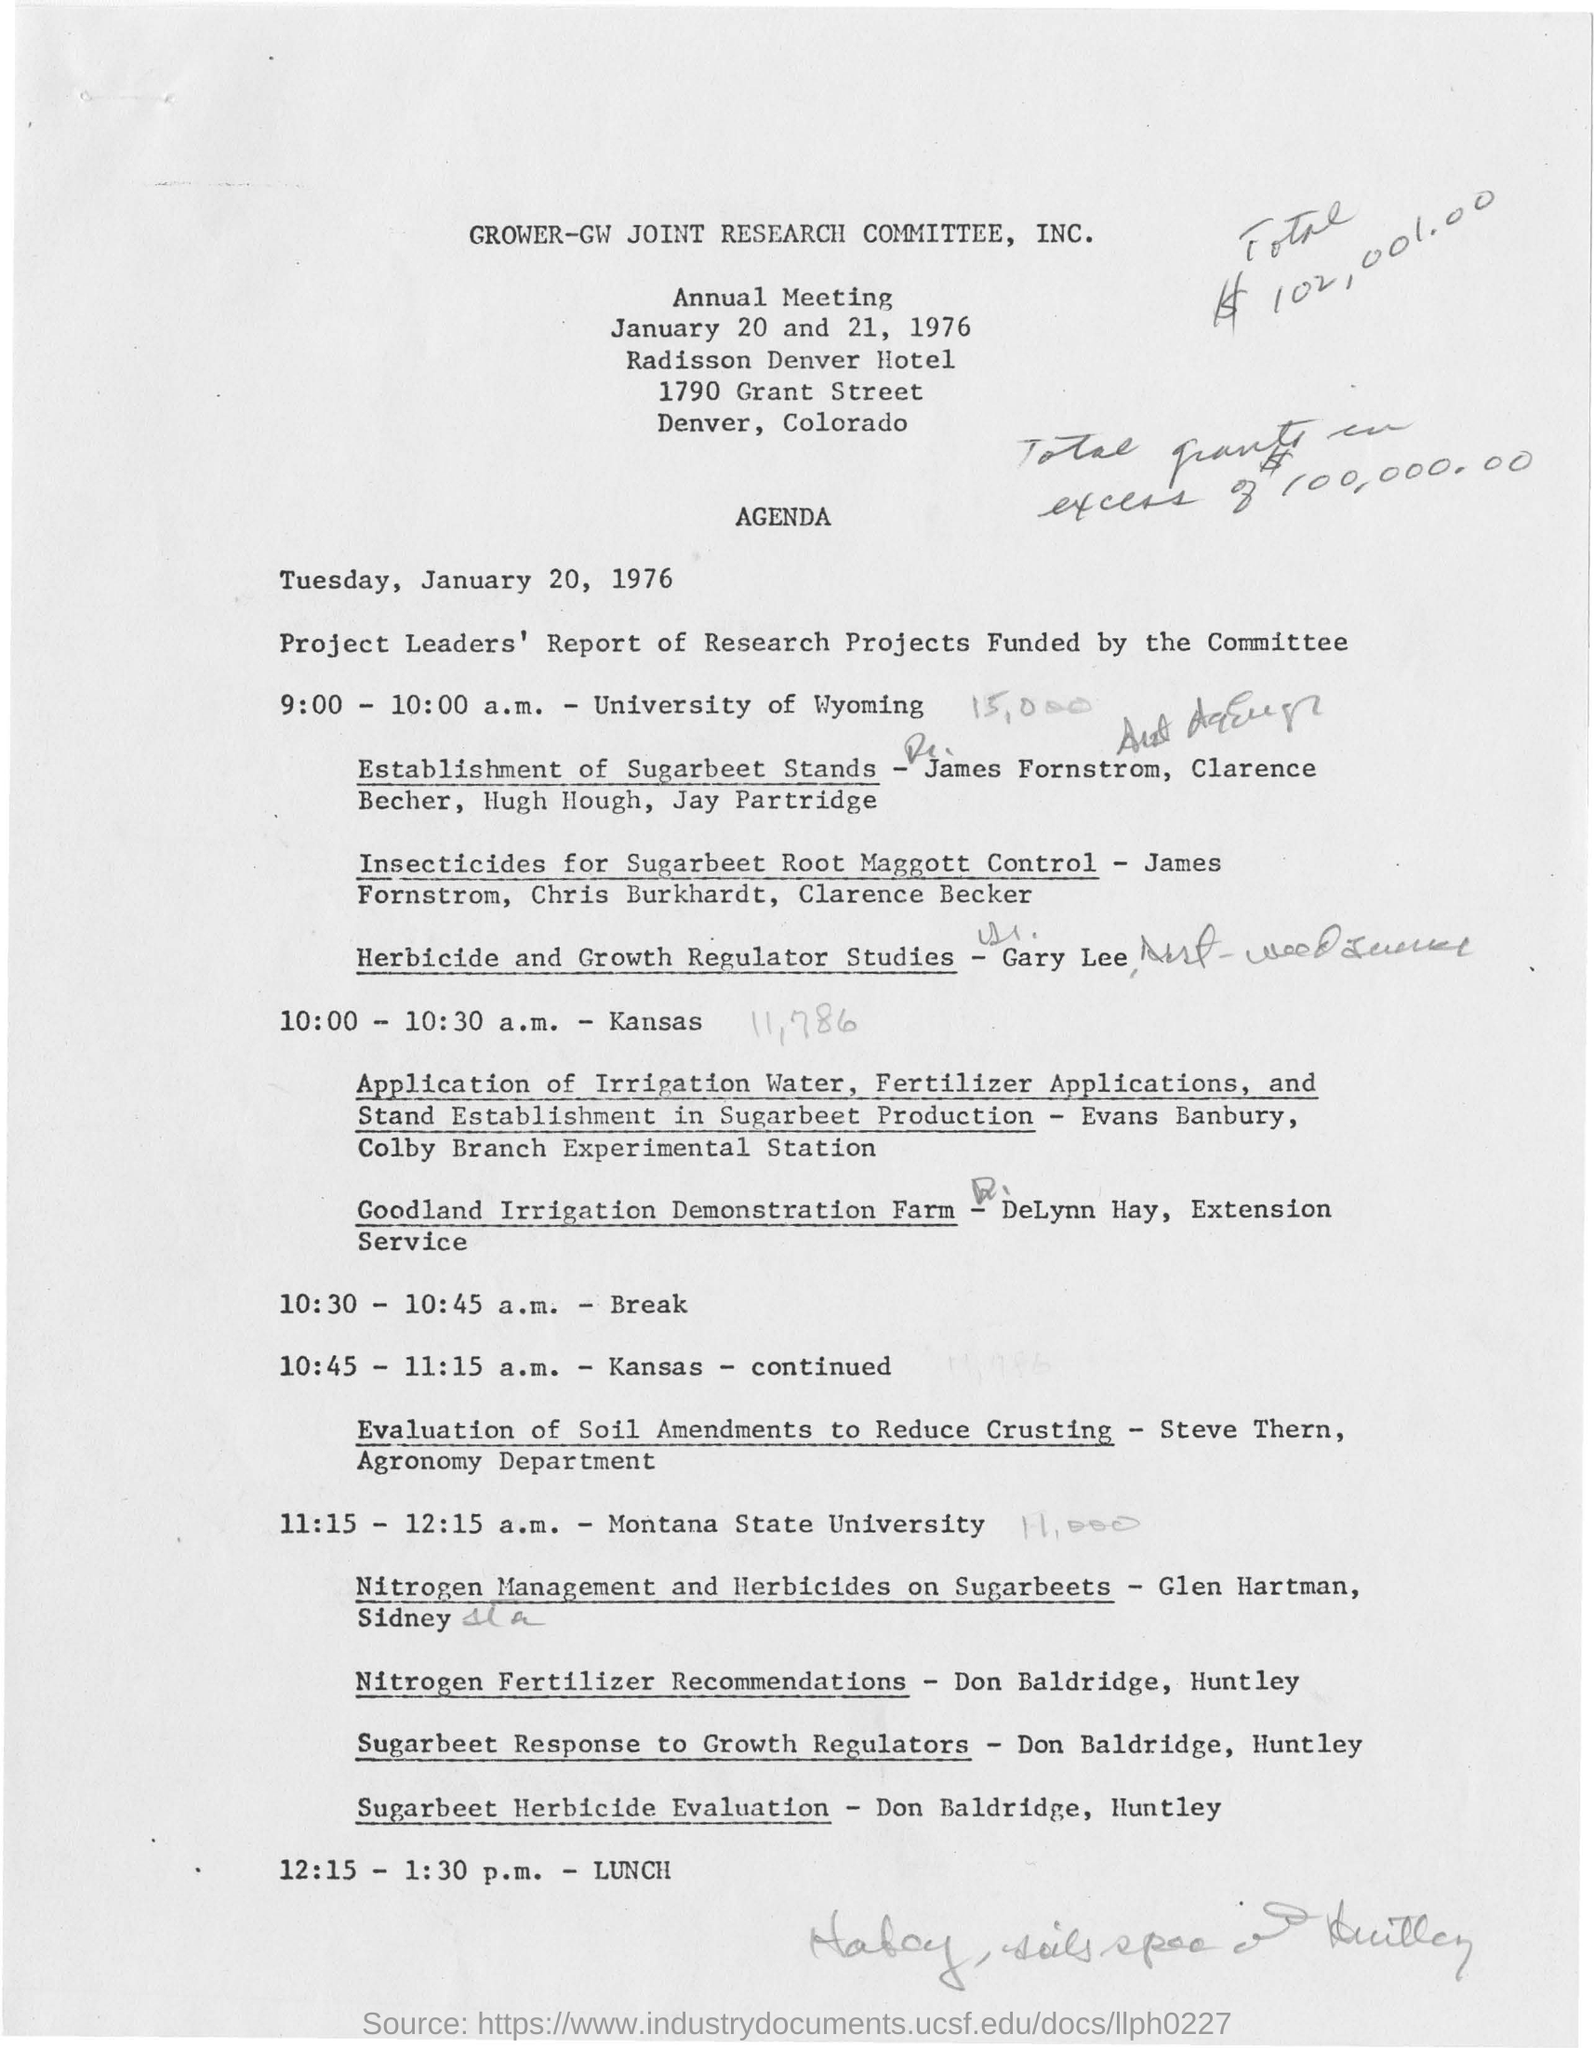On which date GROWER-GW joint research committee annual meeting was held?
Keep it short and to the point. JANUARY 20 AND 21, 1976. What is the lunch time?
Provide a short and direct response. 12:15 -1:30 p.m. Who's department is agronomy?
Provide a short and direct response. Steve thern. When was the annual meeting held?
Make the answer very short. JANUARY 20 AND 21, 1976. 